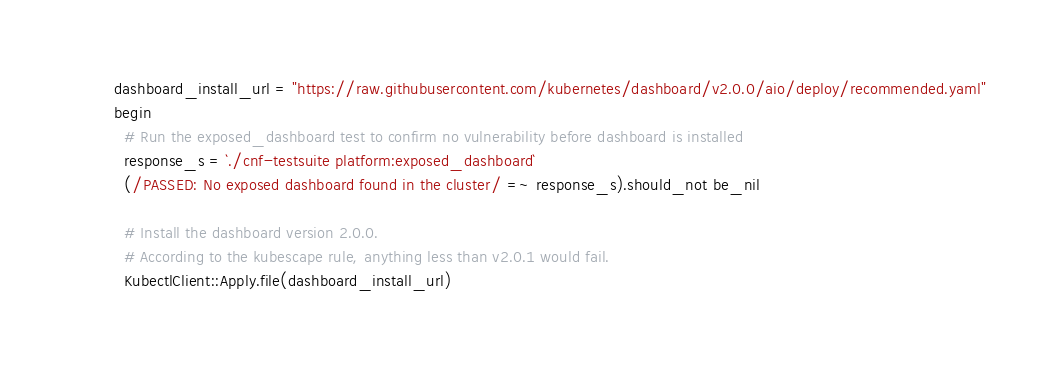<code> <loc_0><loc_0><loc_500><loc_500><_Crystal_>    dashboard_install_url = "https://raw.githubusercontent.com/kubernetes/dashboard/v2.0.0/aio/deploy/recommended.yaml"
    begin
      # Run the exposed_dashboard test to confirm no vulnerability before dashboard is installed
      response_s = `./cnf-testsuite platform:exposed_dashboard`
      (/PASSED: No exposed dashboard found in the cluster/ =~ response_s).should_not be_nil

      # Install the dashboard version 2.0.0.
      # According to the kubescape rule, anything less than v2.0.1 would fail.
      KubectlClient::Apply.file(dashboard_install_url)
</code> 